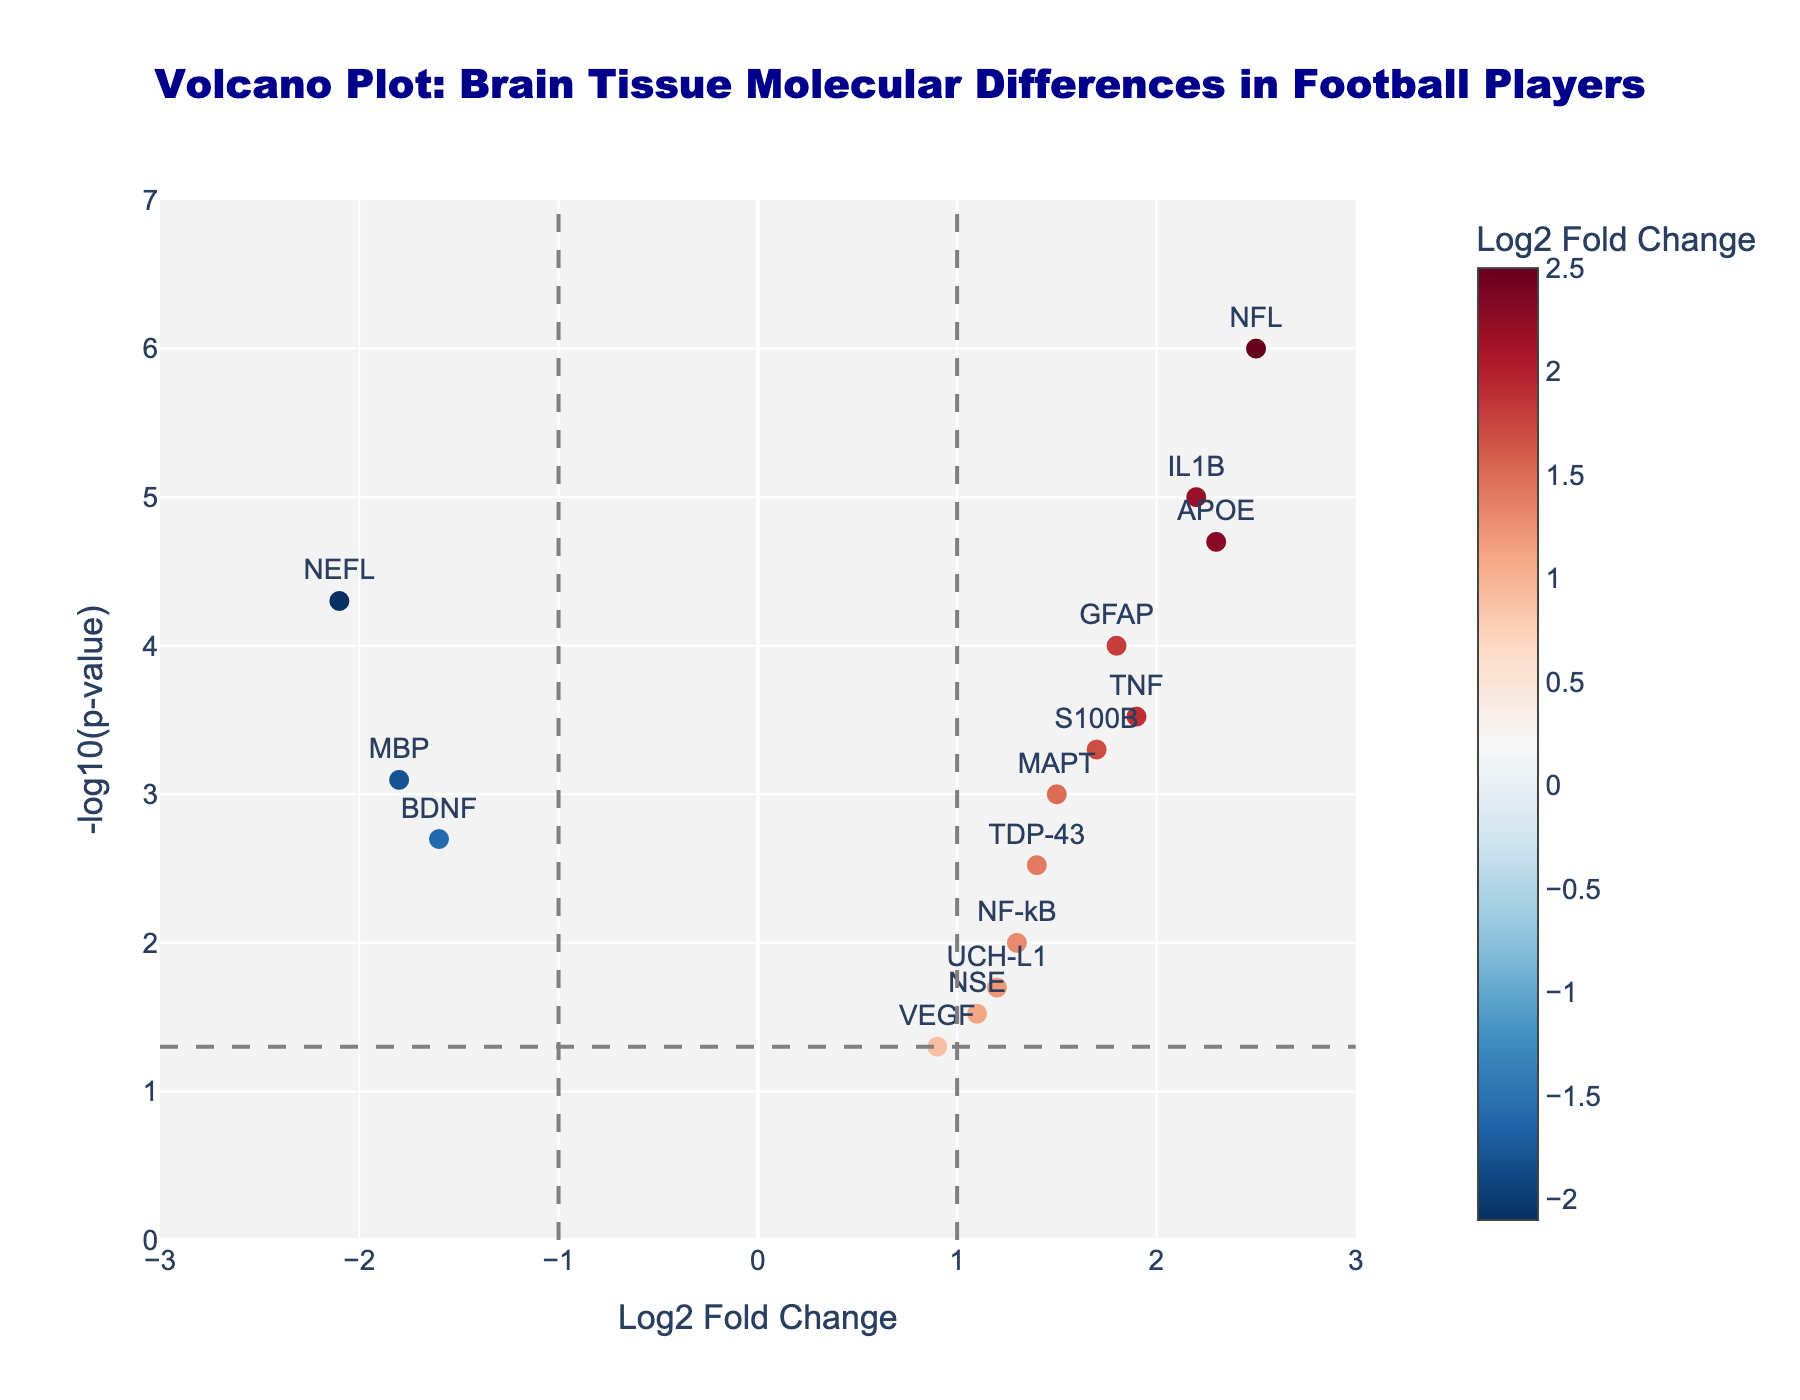What is the title of the plot? The title is usually displayed at the top of the plot. This specific title is centered and is written as: "Volcano Plot: Brain Tissue Molecular Differences in Football Players".
Answer: Volcano Plot: Brain Tissue Molecular Differences in Football Players What are the labels of the x and y axes? The x-axis and y-axis labels are positioned along the respective axes. The x-axis label is "Log2 Fold Change" and the y-axis label is "-log10(p-value)".
Answer: Log2 Fold Change and -log10(p-value) How many genes have a p-value less than 0.05? Genes with p-values less than 0.05 will be above the horizontal dashed line (which is at -log10(0.05)). Count the markers that are positioned above this line.
Answer: 14 Which gene shows the highest Log2 Fold Change? The gene with the highest Log2 Fold Change will be the marker farthest to the right. The hover text or labels will help identify that gene.
Answer: NFL Which data point represents the gene NSE? Find the data point labeled "NSE" in the plot and refer to its hover text or its label position on the axes to get its coordinates.
Answer: Log2FC: 1.1, p-value: 0.03 Which genes are significantly downregulated (Log2 Fold Change < -1 and p-value < 0.05)? Significantly downregulated genes will be on the left side of the plot (Log2 Fold Change < -1) and above the line (p-value < 0.05). Look for markers in that region that have text labels.
Answer: NEFL, BDNF, MBP Compare the p-values of genes GFAP and APOE. Which one is more significant? The significance of a p-value is represented by its -log10(p-value) value on the y-axis. The gene with the higher y-coordinate is more significant.
Answer: APOE What is the fold change threshold used to determine significant upregulation or downregulation? The fold change thresholds are marked by the vertical dashed lines on the plot. These lines are located at Log2 Fold Change = -1 and Log2 Fold Change = 1.
Answer: -1 and 1 Calculate the average Log2 Fold Change of GFAP and TNF. To find the average, sum the Log2 Fold Changes of GFAP and TNF (1.8 + 1.9) and then divide by 2.
Answer: 1.85 Which gene has a Log2 Fold Change close to zero and a non-significant p-value? Look for a data point near the y-axis (Log2 Fold Change close to 0) and below the horizontal dashed line (non-significant p-value). The label or hover text will help identify the gene.
Answer: VEGF 